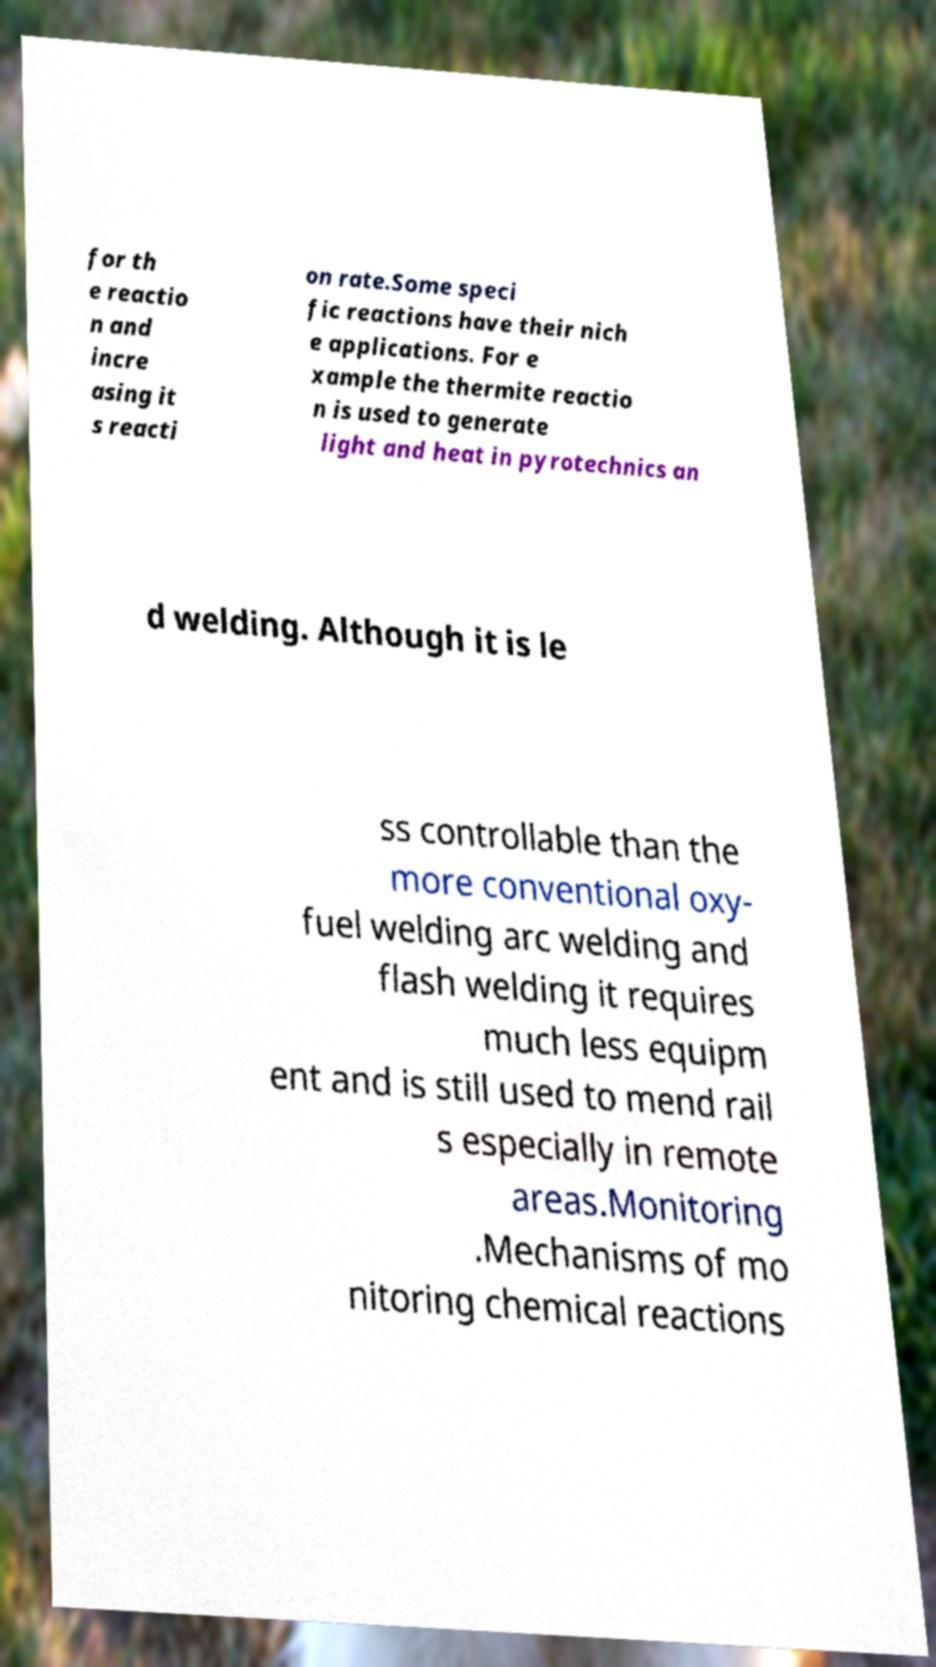Please identify and transcribe the text found in this image. for th e reactio n and incre asing it s reacti on rate.Some speci fic reactions have their nich e applications. For e xample the thermite reactio n is used to generate light and heat in pyrotechnics an d welding. Although it is le ss controllable than the more conventional oxy- fuel welding arc welding and flash welding it requires much less equipm ent and is still used to mend rail s especially in remote areas.Monitoring .Mechanisms of mo nitoring chemical reactions 